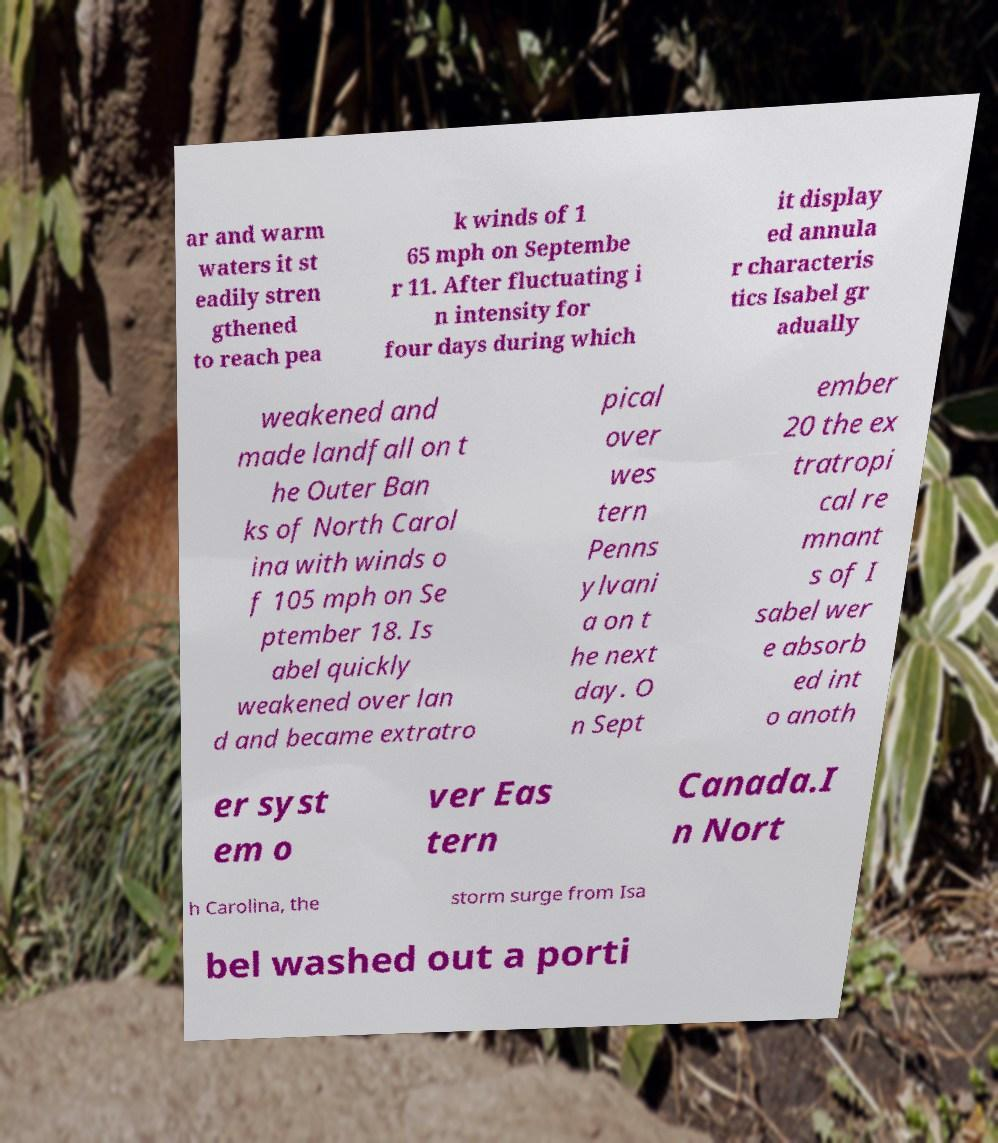Please identify and transcribe the text found in this image. ar and warm waters it st eadily stren gthened to reach pea k winds of 1 65 mph on Septembe r 11. After fluctuating i n intensity for four days during which it display ed annula r characteris tics Isabel gr adually weakened and made landfall on t he Outer Ban ks of North Carol ina with winds o f 105 mph on Se ptember 18. Is abel quickly weakened over lan d and became extratro pical over wes tern Penns ylvani a on t he next day. O n Sept ember 20 the ex tratropi cal re mnant s of I sabel wer e absorb ed int o anoth er syst em o ver Eas tern Canada.I n Nort h Carolina, the storm surge from Isa bel washed out a porti 